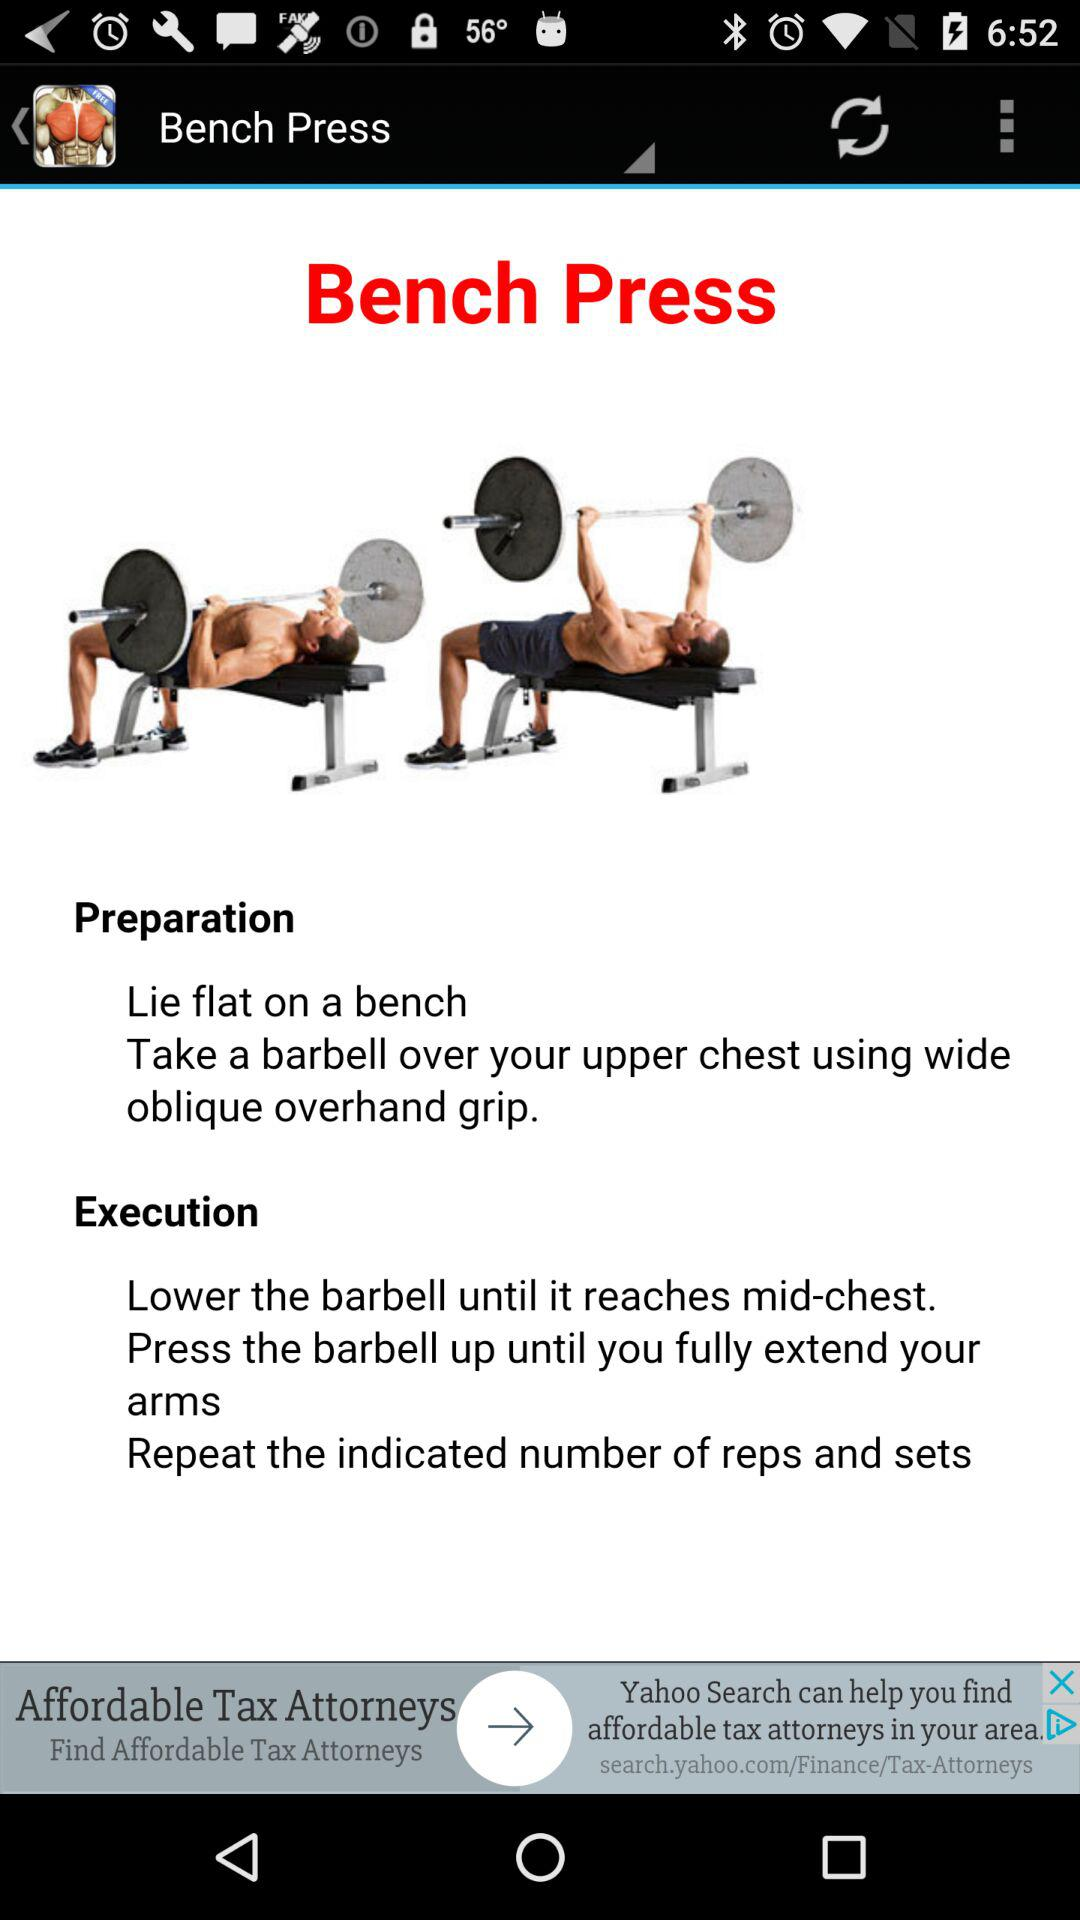What is the selected exercise? The selected exercise is "Bench Press". 